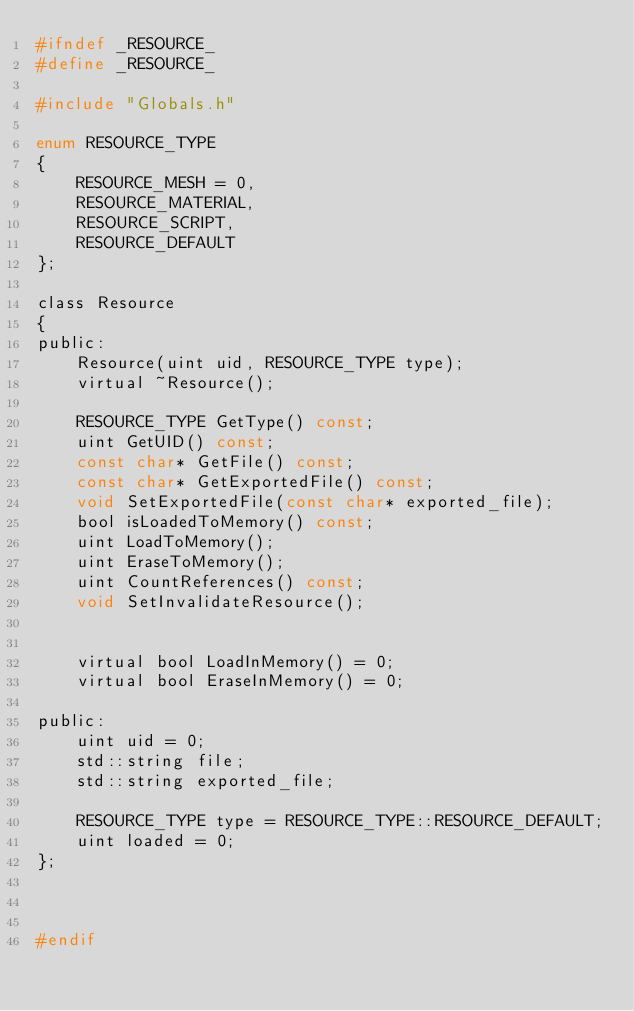<code> <loc_0><loc_0><loc_500><loc_500><_C_>#ifndef _RESOURCE_
#define _RESOURCE_

#include "Globals.h"

enum RESOURCE_TYPE
{
	RESOURCE_MESH = 0,
	RESOURCE_MATERIAL,
	RESOURCE_SCRIPT,
	RESOURCE_DEFAULT
};

class Resource
{
public:
	Resource(uint uid, RESOURCE_TYPE type);
	virtual ~Resource();

	RESOURCE_TYPE GetType() const;
	uint GetUID() const;
	const char* GetFile() const;
	const char* GetExportedFile() const;
	void SetExportedFile(const char* exported_file);
	bool isLoadedToMemory() const;
	uint LoadToMemory();
	uint EraseToMemory();
	uint CountReferences() const;
	void SetInvalidateResource();


	virtual bool LoadInMemory() = 0;
	virtual bool EraseInMemory() = 0;

public:
	uint uid = 0;
	std::string file;
	std::string exported_file;

	RESOURCE_TYPE type = RESOURCE_TYPE::RESOURCE_DEFAULT;
	uint loaded = 0;
};



#endif
</code> 